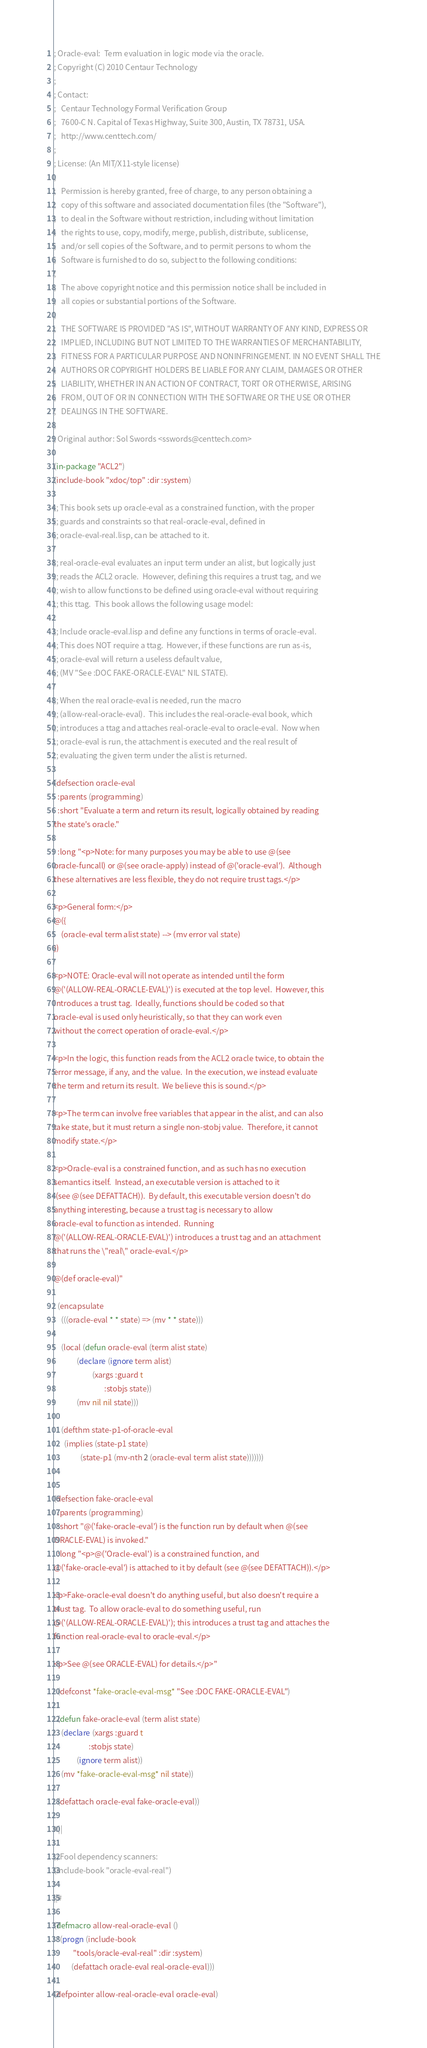<code> <loc_0><loc_0><loc_500><loc_500><_Lisp_>; Oracle-eval:  Term evaluation in logic mode via the oracle.
; Copyright (C) 2010 Centaur Technology
;
; Contact:
;   Centaur Technology Formal Verification Group
;   7600-C N. Capital of Texas Highway, Suite 300, Austin, TX 78731, USA.
;   http://www.centtech.com/
;
; License: (An MIT/X11-style license)
;
;   Permission is hereby granted, free of charge, to any person obtaining a
;   copy of this software and associated documentation files (the "Software"),
;   to deal in the Software without restriction, including without limitation
;   the rights to use, copy, modify, merge, publish, distribute, sublicense,
;   and/or sell copies of the Software, and to permit persons to whom the
;   Software is furnished to do so, subject to the following conditions:
;
;   The above copyright notice and this permission notice shall be included in
;   all copies or substantial portions of the Software.
;
;   THE SOFTWARE IS PROVIDED "AS IS", WITHOUT WARRANTY OF ANY KIND, EXPRESS OR
;   IMPLIED, INCLUDING BUT NOT LIMITED TO THE WARRANTIES OF MERCHANTABILITY,
;   FITNESS FOR A PARTICULAR PURPOSE AND NONINFRINGEMENT. IN NO EVENT SHALL THE
;   AUTHORS OR COPYRIGHT HOLDERS BE LIABLE FOR ANY CLAIM, DAMAGES OR OTHER
;   LIABILITY, WHETHER IN AN ACTION OF CONTRACT, TORT OR OTHERWISE, ARISING
;   FROM, OUT OF OR IN CONNECTION WITH THE SOFTWARE OR THE USE OR OTHER
;   DEALINGS IN THE SOFTWARE.
;
; Original author: Sol Swords <sswords@centtech.com>

(in-package "ACL2")
(include-book "xdoc/top" :dir :system)

;; This book sets up oracle-eval as a constrained function, with the proper
;; guards and constraints so that real-oracle-eval, defined in
;; oracle-eval-real.lisp, can be attached to it.

;; real-oracle-eval evaluates an input term under an alist, but logically just
;; reads the ACL2 oracle.  However, defining this requires a trust tag, and we
;; wish to allow functions to be defined using oracle-eval without requiring
;; this ttag.  This book allows the following usage model:

;; Include oracle-eval.lisp and define any functions in terms of oracle-eval.
;; This does NOT require a ttag.  However, if these functions are run as-is,
;; oracle-eval will return a useless default value,
;; (MV "See :DOC FAKE-ORACLE-EVAL" NIL STATE).

;; When the real oracle-eval is needed, run the macro
;; (allow-real-oracle-eval).  This includes the real-oracle-eval book, which
;; introduces a ttag and attaches real-oracle-eval to oracle-eval.  Now when
;; oracle-eval is run, the attachment is executed and the real result of
;; evaluating the given term under the alist is returned.

(defsection oracle-eval
  :parents (programming)
  :short "Evaluate a term and return its result, logically obtained by reading
the state's oracle."

  :long "<p>Note: for many purposes you may be able to use @(see
oracle-funcall) or @(see oracle-apply) instead of @('oracle-eval').  Although
these alternatives are less flexible, they do not require trust tags.</p>

<p>General form:</p>
@({
    (oracle-eval term alist state) --> (mv error val state)
})

<p>NOTE: Oracle-eval will not operate as intended until the form
@('(ALLOW-REAL-ORACLE-EVAL)') is executed at the top level.  However, this
introduces a trust tag.  Ideally, functions should be coded so that
oracle-eval is used only heuristically, so that they can work even
without the correct operation of oracle-eval.</p>

<p>In the logic, this function reads from the ACL2 oracle twice, to obtain the
error message, if any, and the value.  In the execution, we instead evaluate
the term and return its result.  We believe this is sound.</p>

<p>The term can involve free variables that appear in the alist, and can also
take state, but it must return a single non-stobj value.  Therefore, it cannot
modify state.</p>

<p>Oracle-eval is a constrained function, and as such has no execution
semantics itself.  Instead, an executable version is attached to it
 (see @(see DEFATTACH)).  By default, this executable version doesn't do
anything interesting, because a trust tag is necessary to allow
oracle-eval to function as intended.  Running
@('(ALLOW-REAL-ORACLE-EVAL)') introduces a trust tag and an attachment
that runs the \"real\" oracle-eval.</p>

@(def oracle-eval)"

  (encapsulate
    (((oracle-eval * * state) => (mv * * state)))

    (local (defun oracle-eval (term alist state)
             (declare (ignore term alist)
                      (xargs :guard t
                             :stobjs state))
             (mv nil nil state)))

    (defthm state-p1-of-oracle-eval
      (implies (state-p1 state)
               (state-p1 (mv-nth 2 (oracle-eval term alist state)))))))


(defsection fake-oracle-eval
  :parents (programming)
  :short "@('fake-oracle-eval') is the function run by default when @(see
ORACLE-EVAL) is invoked."
  :long "<p>@('Oracle-eval') is a constrained function, and
@('fake-oracle-eval') is attached to it by default (see @(see DEFATTACH)).</p>

<p>Fake-oracle-eval doesn't do anything useful, but also doesn't require a
trust tag.  To allow oracle-eval to do something useful, run
@('(ALLOW-REAL-ORACLE-EVAL)'); this introduces a trust tag and attaches the
function real-oracle-eval to oracle-eval.</p>

<p>See @(see ORACLE-EVAL) for details.</p>"

  (defconst *fake-oracle-eval-msg* "See :DOC FAKE-ORACLE-EVAL")

  (defun fake-oracle-eval (term alist state)
    (declare (xargs :guard t
                    :stobjs state)
             (ignore term alist))
    (mv *fake-oracle-eval-msg* nil state))

  (defattach oracle-eval fake-oracle-eval))

#||

;; Fool dependency scanners:
(include-book "oracle-eval-real")

||#

(defmacro allow-real-oracle-eval ()
  '(progn (include-book
           "tools/oracle-eval-real" :dir :system)
          (defattach oracle-eval real-oracle-eval)))

(defpointer allow-real-oracle-eval oracle-eval)
</code> 